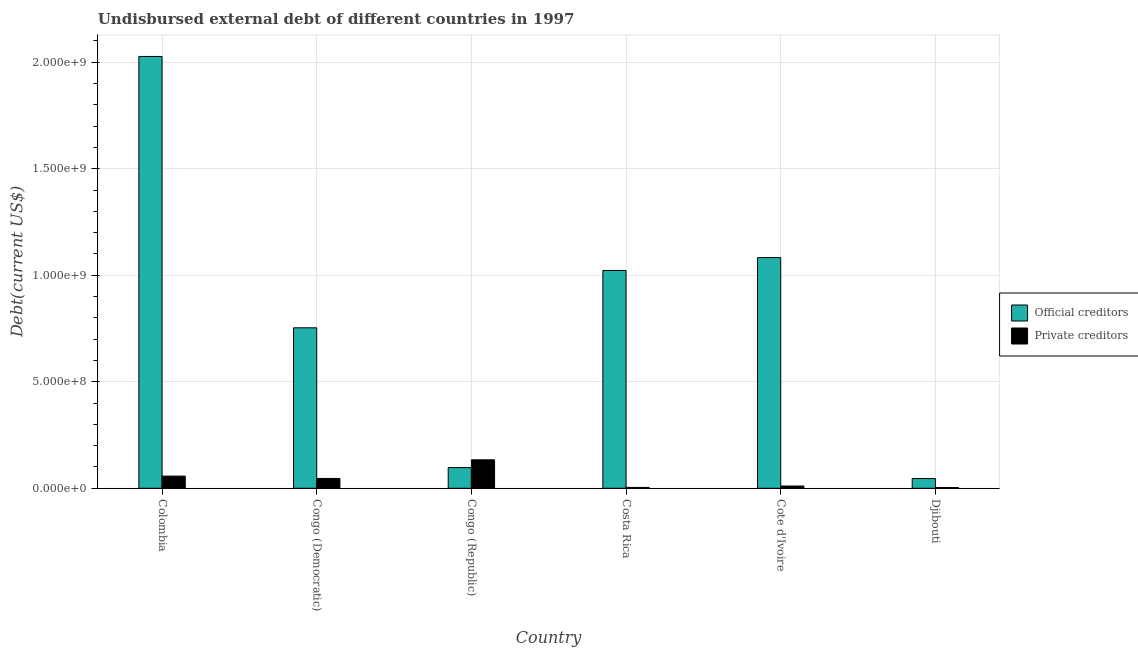How many different coloured bars are there?
Ensure brevity in your answer.  2. How many bars are there on the 4th tick from the right?
Your answer should be very brief. 2. What is the label of the 6th group of bars from the left?
Keep it short and to the point. Djibouti. In how many cases, is the number of bars for a given country not equal to the number of legend labels?
Provide a short and direct response. 0. What is the undisbursed external debt of official creditors in Djibouti?
Your answer should be very brief. 4.57e+07. Across all countries, what is the maximum undisbursed external debt of private creditors?
Make the answer very short. 1.34e+08. Across all countries, what is the minimum undisbursed external debt of official creditors?
Ensure brevity in your answer.  4.57e+07. In which country was the undisbursed external debt of private creditors minimum?
Offer a very short reply. Djibouti. What is the total undisbursed external debt of private creditors in the graph?
Offer a terse response. 2.55e+08. What is the difference between the undisbursed external debt of private creditors in Congo (Republic) and that in Djibouti?
Provide a succinct answer. 1.30e+08. What is the difference between the undisbursed external debt of private creditors in Congo (Republic) and the undisbursed external debt of official creditors in Congo (Democratic)?
Provide a succinct answer. -6.20e+08. What is the average undisbursed external debt of private creditors per country?
Your answer should be very brief. 4.25e+07. What is the difference between the undisbursed external debt of private creditors and undisbursed external debt of official creditors in Djibouti?
Keep it short and to the point. -4.21e+07. In how many countries, is the undisbursed external debt of private creditors greater than 1900000000 US$?
Your response must be concise. 0. What is the ratio of the undisbursed external debt of private creditors in Congo (Democratic) to that in Costa Rica?
Provide a short and direct response. 11.44. Is the undisbursed external debt of official creditors in Congo (Democratic) less than that in Costa Rica?
Offer a very short reply. Yes. Is the difference between the undisbursed external debt of official creditors in Colombia and Cote d'Ivoire greater than the difference between the undisbursed external debt of private creditors in Colombia and Cote d'Ivoire?
Give a very brief answer. Yes. What is the difference between the highest and the second highest undisbursed external debt of private creditors?
Your answer should be compact. 7.65e+07. What is the difference between the highest and the lowest undisbursed external debt of private creditors?
Keep it short and to the point. 1.30e+08. Is the sum of the undisbursed external debt of private creditors in Costa Rica and Cote d'Ivoire greater than the maximum undisbursed external debt of official creditors across all countries?
Ensure brevity in your answer.  No. What does the 1st bar from the left in Costa Rica represents?
Keep it short and to the point. Official creditors. What does the 2nd bar from the right in Cote d'Ivoire represents?
Provide a succinct answer. Official creditors. How many countries are there in the graph?
Provide a short and direct response. 6. Where does the legend appear in the graph?
Make the answer very short. Center right. How many legend labels are there?
Offer a very short reply. 2. How are the legend labels stacked?
Ensure brevity in your answer.  Vertical. What is the title of the graph?
Offer a very short reply. Undisbursed external debt of different countries in 1997. What is the label or title of the Y-axis?
Your answer should be very brief. Debt(current US$). What is the Debt(current US$) of Official creditors in Colombia?
Offer a very short reply. 2.03e+09. What is the Debt(current US$) of Private creditors in Colombia?
Keep it short and to the point. 5.71e+07. What is the Debt(current US$) in Official creditors in Congo (Democratic)?
Offer a terse response. 7.53e+08. What is the Debt(current US$) in Private creditors in Congo (Democratic)?
Give a very brief answer. 4.61e+07. What is the Debt(current US$) of Official creditors in Congo (Republic)?
Your answer should be very brief. 9.72e+07. What is the Debt(current US$) of Private creditors in Congo (Republic)?
Your answer should be compact. 1.34e+08. What is the Debt(current US$) of Official creditors in Costa Rica?
Provide a succinct answer. 1.02e+09. What is the Debt(current US$) of Private creditors in Costa Rica?
Offer a terse response. 4.03e+06. What is the Debt(current US$) of Official creditors in Cote d'Ivoire?
Make the answer very short. 1.08e+09. What is the Debt(current US$) of Private creditors in Cote d'Ivoire?
Offer a very short reply. 1.06e+07. What is the Debt(current US$) of Official creditors in Djibouti?
Your answer should be compact. 4.57e+07. What is the Debt(current US$) of Private creditors in Djibouti?
Offer a terse response. 3.57e+06. Across all countries, what is the maximum Debt(current US$) of Official creditors?
Give a very brief answer. 2.03e+09. Across all countries, what is the maximum Debt(current US$) of Private creditors?
Your answer should be very brief. 1.34e+08. Across all countries, what is the minimum Debt(current US$) in Official creditors?
Your answer should be compact. 4.57e+07. Across all countries, what is the minimum Debt(current US$) of Private creditors?
Give a very brief answer. 3.57e+06. What is the total Debt(current US$) of Official creditors in the graph?
Give a very brief answer. 5.03e+09. What is the total Debt(current US$) of Private creditors in the graph?
Your answer should be compact. 2.55e+08. What is the difference between the Debt(current US$) in Official creditors in Colombia and that in Congo (Democratic)?
Keep it short and to the point. 1.27e+09. What is the difference between the Debt(current US$) of Private creditors in Colombia and that in Congo (Democratic)?
Make the answer very short. 1.10e+07. What is the difference between the Debt(current US$) of Official creditors in Colombia and that in Congo (Republic)?
Give a very brief answer. 1.93e+09. What is the difference between the Debt(current US$) in Private creditors in Colombia and that in Congo (Republic)?
Offer a terse response. -7.65e+07. What is the difference between the Debt(current US$) in Official creditors in Colombia and that in Costa Rica?
Provide a succinct answer. 1.00e+09. What is the difference between the Debt(current US$) of Private creditors in Colombia and that in Costa Rica?
Provide a short and direct response. 5.31e+07. What is the difference between the Debt(current US$) of Official creditors in Colombia and that in Cote d'Ivoire?
Give a very brief answer. 9.44e+08. What is the difference between the Debt(current US$) in Private creditors in Colombia and that in Cote d'Ivoire?
Offer a very short reply. 4.65e+07. What is the difference between the Debt(current US$) in Official creditors in Colombia and that in Djibouti?
Offer a very short reply. 1.98e+09. What is the difference between the Debt(current US$) in Private creditors in Colombia and that in Djibouti?
Provide a succinct answer. 5.36e+07. What is the difference between the Debt(current US$) in Official creditors in Congo (Democratic) and that in Congo (Republic)?
Keep it short and to the point. 6.56e+08. What is the difference between the Debt(current US$) of Private creditors in Congo (Democratic) and that in Congo (Republic)?
Ensure brevity in your answer.  -8.75e+07. What is the difference between the Debt(current US$) in Official creditors in Congo (Democratic) and that in Costa Rica?
Provide a succinct answer. -2.69e+08. What is the difference between the Debt(current US$) of Private creditors in Congo (Democratic) and that in Costa Rica?
Provide a succinct answer. 4.21e+07. What is the difference between the Debt(current US$) of Official creditors in Congo (Democratic) and that in Cote d'Ivoire?
Provide a succinct answer. -3.30e+08. What is the difference between the Debt(current US$) of Private creditors in Congo (Democratic) and that in Cote d'Ivoire?
Make the answer very short. 3.55e+07. What is the difference between the Debt(current US$) in Official creditors in Congo (Democratic) and that in Djibouti?
Ensure brevity in your answer.  7.08e+08. What is the difference between the Debt(current US$) in Private creditors in Congo (Democratic) and that in Djibouti?
Make the answer very short. 4.26e+07. What is the difference between the Debt(current US$) of Official creditors in Congo (Republic) and that in Costa Rica?
Make the answer very short. -9.25e+08. What is the difference between the Debt(current US$) of Private creditors in Congo (Republic) and that in Costa Rica?
Offer a terse response. 1.30e+08. What is the difference between the Debt(current US$) of Official creditors in Congo (Republic) and that in Cote d'Ivoire?
Make the answer very short. -9.86e+08. What is the difference between the Debt(current US$) in Private creditors in Congo (Republic) and that in Cote d'Ivoire?
Offer a terse response. 1.23e+08. What is the difference between the Debt(current US$) in Official creditors in Congo (Republic) and that in Djibouti?
Give a very brief answer. 5.14e+07. What is the difference between the Debt(current US$) in Private creditors in Congo (Republic) and that in Djibouti?
Your answer should be very brief. 1.30e+08. What is the difference between the Debt(current US$) in Official creditors in Costa Rica and that in Cote d'Ivoire?
Your answer should be compact. -6.06e+07. What is the difference between the Debt(current US$) of Private creditors in Costa Rica and that in Cote d'Ivoire?
Your response must be concise. -6.55e+06. What is the difference between the Debt(current US$) in Official creditors in Costa Rica and that in Djibouti?
Offer a very short reply. 9.77e+08. What is the difference between the Debt(current US$) of Private creditors in Costa Rica and that in Djibouti?
Your answer should be compact. 4.62e+05. What is the difference between the Debt(current US$) in Official creditors in Cote d'Ivoire and that in Djibouti?
Your answer should be compact. 1.04e+09. What is the difference between the Debt(current US$) of Private creditors in Cote d'Ivoire and that in Djibouti?
Ensure brevity in your answer.  7.01e+06. What is the difference between the Debt(current US$) of Official creditors in Colombia and the Debt(current US$) of Private creditors in Congo (Democratic)?
Give a very brief answer. 1.98e+09. What is the difference between the Debt(current US$) of Official creditors in Colombia and the Debt(current US$) of Private creditors in Congo (Republic)?
Your response must be concise. 1.89e+09. What is the difference between the Debt(current US$) in Official creditors in Colombia and the Debt(current US$) in Private creditors in Costa Rica?
Offer a very short reply. 2.02e+09. What is the difference between the Debt(current US$) in Official creditors in Colombia and the Debt(current US$) in Private creditors in Cote d'Ivoire?
Your response must be concise. 2.02e+09. What is the difference between the Debt(current US$) in Official creditors in Colombia and the Debt(current US$) in Private creditors in Djibouti?
Offer a terse response. 2.02e+09. What is the difference between the Debt(current US$) of Official creditors in Congo (Democratic) and the Debt(current US$) of Private creditors in Congo (Republic)?
Provide a short and direct response. 6.20e+08. What is the difference between the Debt(current US$) in Official creditors in Congo (Democratic) and the Debt(current US$) in Private creditors in Costa Rica?
Keep it short and to the point. 7.49e+08. What is the difference between the Debt(current US$) of Official creditors in Congo (Democratic) and the Debt(current US$) of Private creditors in Cote d'Ivoire?
Give a very brief answer. 7.43e+08. What is the difference between the Debt(current US$) in Official creditors in Congo (Democratic) and the Debt(current US$) in Private creditors in Djibouti?
Give a very brief answer. 7.50e+08. What is the difference between the Debt(current US$) of Official creditors in Congo (Republic) and the Debt(current US$) of Private creditors in Costa Rica?
Keep it short and to the point. 9.31e+07. What is the difference between the Debt(current US$) in Official creditors in Congo (Republic) and the Debt(current US$) in Private creditors in Cote d'Ivoire?
Offer a terse response. 8.66e+07. What is the difference between the Debt(current US$) of Official creditors in Congo (Republic) and the Debt(current US$) of Private creditors in Djibouti?
Give a very brief answer. 9.36e+07. What is the difference between the Debt(current US$) in Official creditors in Costa Rica and the Debt(current US$) in Private creditors in Cote d'Ivoire?
Keep it short and to the point. 1.01e+09. What is the difference between the Debt(current US$) of Official creditors in Costa Rica and the Debt(current US$) of Private creditors in Djibouti?
Provide a succinct answer. 1.02e+09. What is the difference between the Debt(current US$) in Official creditors in Cote d'Ivoire and the Debt(current US$) in Private creditors in Djibouti?
Give a very brief answer. 1.08e+09. What is the average Debt(current US$) of Official creditors per country?
Provide a short and direct response. 8.38e+08. What is the average Debt(current US$) in Private creditors per country?
Offer a very short reply. 4.25e+07. What is the difference between the Debt(current US$) in Official creditors and Debt(current US$) in Private creditors in Colombia?
Your response must be concise. 1.97e+09. What is the difference between the Debt(current US$) in Official creditors and Debt(current US$) in Private creditors in Congo (Democratic)?
Give a very brief answer. 7.07e+08. What is the difference between the Debt(current US$) in Official creditors and Debt(current US$) in Private creditors in Congo (Republic)?
Offer a terse response. -3.64e+07. What is the difference between the Debt(current US$) of Official creditors and Debt(current US$) of Private creditors in Costa Rica?
Offer a terse response. 1.02e+09. What is the difference between the Debt(current US$) of Official creditors and Debt(current US$) of Private creditors in Cote d'Ivoire?
Provide a short and direct response. 1.07e+09. What is the difference between the Debt(current US$) of Official creditors and Debt(current US$) of Private creditors in Djibouti?
Provide a succinct answer. 4.21e+07. What is the ratio of the Debt(current US$) of Official creditors in Colombia to that in Congo (Democratic)?
Provide a succinct answer. 2.69. What is the ratio of the Debt(current US$) in Private creditors in Colombia to that in Congo (Democratic)?
Your answer should be very brief. 1.24. What is the ratio of the Debt(current US$) in Official creditors in Colombia to that in Congo (Republic)?
Provide a succinct answer. 20.86. What is the ratio of the Debt(current US$) in Private creditors in Colombia to that in Congo (Republic)?
Give a very brief answer. 0.43. What is the ratio of the Debt(current US$) of Official creditors in Colombia to that in Costa Rica?
Make the answer very short. 1.98. What is the ratio of the Debt(current US$) in Private creditors in Colombia to that in Costa Rica?
Offer a very short reply. 14.17. What is the ratio of the Debt(current US$) of Official creditors in Colombia to that in Cote d'Ivoire?
Your answer should be compact. 1.87. What is the ratio of the Debt(current US$) of Private creditors in Colombia to that in Cote d'Ivoire?
Ensure brevity in your answer.  5.4. What is the ratio of the Debt(current US$) of Official creditors in Colombia to that in Djibouti?
Your answer should be very brief. 44.34. What is the ratio of the Debt(current US$) in Private creditors in Colombia to that in Djibouti?
Make the answer very short. 16. What is the ratio of the Debt(current US$) in Official creditors in Congo (Democratic) to that in Congo (Republic)?
Provide a short and direct response. 7.75. What is the ratio of the Debt(current US$) in Private creditors in Congo (Democratic) to that in Congo (Republic)?
Your response must be concise. 0.35. What is the ratio of the Debt(current US$) in Official creditors in Congo (Democratic) to that in Costa Rica?
Keep it short and to the point. 0.74. What is the ratio of the Debt(current US$) of Private creditors in Congo (Democratic) to that in Costa Rica?
Your response must be concise. 11.44. What is the ratio of the Debt(current US$) of Official creditors in Congo (Democratic) to that in Cote d'Ivoire?
Ensure brevity in your answer.  0.7. What is the ratio of the Debt(current US$) in Private creditors in Congo (Democratic) to that in Cote d'Ivoire?
Offer a very short reply. 4.36. What is the ratio of the Debt(current US$) of Official creditors in Congo (Democratic) to that in Djibouti?
Ensure brevity in your answer.  16.48. What is the ratio of the Debt(current US$) in Private creditors in Congo (Democratic) to that in Djibouti?
Ensure brevity in your answer.  12.92. What is the ratio of the Debt(current US$) of Official creditors in Congo (Republic) to that in Costa Rica?
Your answer should be compact. 0.1. What is the ratio of the Debt(current US$) in Private creditors in Congo (Republic) to that in Costa Rica?
Give a very brief answer. 33.13. What is the ratio of the Debt(current US$) in Official creditors in Congo (Republic) to that in Cote d'Ivoire?
Offer a terse response. 0.09. What is the ratio of the Debt(current US$) of Private creditors in Congo (Republic) to that in Cote d'Ivoire?
Your answer should be compact. 12.62. What is the ratio of the Debt(current US$) of Official creditors in Congo (Republic) to that in Djibouti?
Your answer should be very brief. 2.13. What is the ratio of the Debt(current US$) of Private creditors in Congo (Republic) to that in Djibouti?
Your answer should be compact. 37.42. What is the ratio of the Debt(current US$) in Official creditors in Costa Rica to that in Cote d'Ivoire?
Offer a terse response. 0.94. What is the ratio of the Debt(current US$) of Private creditors in Costa Rica to that in Cote d'Ivoire?
Give a very brief answer. 0.38. What is the ratio of the Debt(current US$) of Official creditors in Costa Rica to that in Djibouti?
Offer a terse response. 22.37. What is the ratio of the Debt(current US$) in Private creditors in Costa Rica to that in Djibouti?
Your answer should be compact. 1.13. What is the ratio of the Debt(current US$) in Official creditors in Cote d'Ivoire to that in Djibouti?
Offer a terse response. 23.69. What is the ratio of the Debt(current US$) in Private creditors in Cote d'Ivoire to that in Djibouti?
Keep it short and to the point. 2.96. What is the difference between the highest and the second highest Debt(current US$) of Official creditors?
Your response must be concise. 9.44e+08. What is the difference between the highest and the second highest Debt(current US$) of Private creditors?
Your answer should be very brief. 7.65e+07. What is the difference between the highest and the lowest Debt(current US$) in Official creditors?
Ensure brevity in your answer.  1.98e+09. What is the difference between the highest and the lowest Debt(current US$) of Private creditors?
Offer a very short reply. 1.30e+08. 